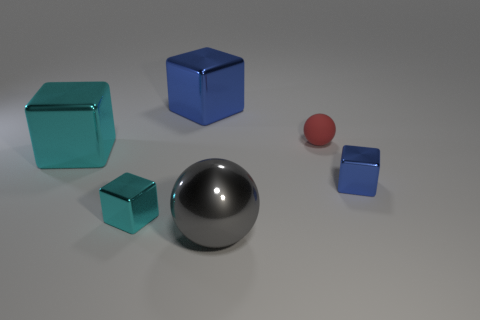Are there any other things that are made of the same material as the tiny sphere?
Offer a terse response. No. What is the material of the tiny ball?
Make the answer very short. Rubber. There is a block that is in front of the big cyan metal object and to the left of the tiny matte ball; what is its size?
Offer a terse response. Small. The gray thing that is made of the same material as the small cyan cube is what shape?
Your answer should be very brief. Sphere. Do the gray ball and the red object that is to the left of the small blue metal thing have the same material?
Offer a terse response. No. There is a cyan block that is behind the small blue metallic block; are there any blue metallic things in front of it?
Your answer should be compact. Yes. What is the material of the gray object that is the same shape as the tiny red rubber object?
Provide a succinct answer. Metal. What number of small blocks are in front of the blue thing in front of the small red sphere?
Offer a terse response. 1. Are there any other things that are the same color as the tiny rubber ball?
Your answer should be compact. No. How many things are either gray balls or objects behind the small cyan thing?
Provide a short and direct response. 5. 